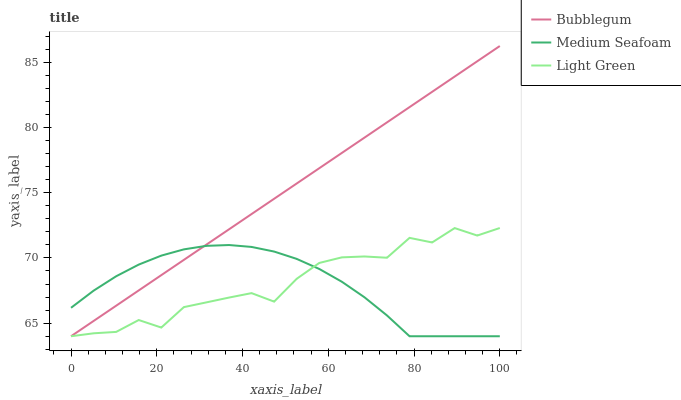Does Bubblegum have the minimum area under the curve?
Answer yes or no. No. Does Medium Seafoam have the maximum area under the curve?
Answer yes or no. No. Is Medium Seafoam the smoothest?
Answer yes or no. No. Is Medium Seafoam the roughest?
Answer yes or no. No. Does Medium Seafoam have the highest value?
Answer yes or no. No. 